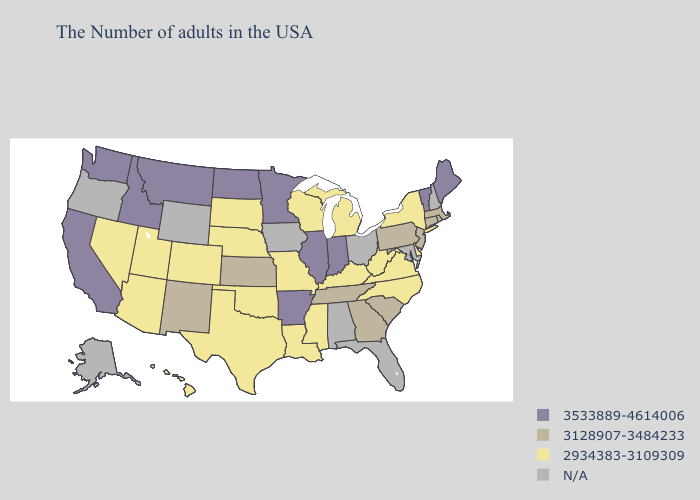Name the states that have a value in the range 3533889-4614006?
Keep it brief. Maine, Vermont, Indiana, Illinois, Arkansas, Minnesota, North Dakota, Montana, Idaho, California, Washington. Name the states that have a value in the range 3533889-4614006?
Short answer required. Maine, Vermont, Indiana, Illinois, Arkansas, Minnesota, North Dakota, Montana, Idaho, California, Washington. Does Arkansas have the highest value in the South?
Write a very short answer. Yes. What is the value of Connecticut?
Short answer required. 3128907-3484233. What is the lowest value in the West?
Keep it brief. 2934383-3109309. Name the states that have a value in the range N/A?
Quick response, please. New Hampshire, Maryland, Ohio, Florida, Alabama, Iowa, Wyoming, Oregon, Alaska. Name the states that have a value in the range 2934383-3109309?
Quick response, please. New York, Delaware, Virginia, North Carolina, West Virginia, Michigan, Kentucky, Wisconsin, Mississippi, Louisiana, Missouri, Nebraska, Oklahoma, Texas, South Dakota, Colorado, Utah, Arizona, Nevada, Hawaii. Name the states that have a value in the range N/A?
Be succinct. New Hampshire, Maryland, Ohio, Florida, Alabama, Iowa, Wyoming, Oregon, Alaska. Name the states that have a value in the range 3128907-3484233?
Short answer required. Massachusetts, Rhode Island, Connecticut, New Jersey, Pennsylvania, South Carolina, Georgia, Tennessee, Kansas, New Mexico. Does the map have missing data?
Write a very short answer. Yes. Name the states that have a value in the range 3128907-3484233?
Be succinct. Massachusetts, Rhode Island, Connecticut, New Jersey, Pennsylvania, South Carolina, Georgia, Tennessee, Kansas, New Mexico. What is the highest value in states that border New Jersey?
Be succinct. 3128907-3484233. What is the lowest value in the MidWest?
Quick response, please. 2934383-3109309. What is the highest value in states that border Colorado?
Give a very brief answer. 3128907-3484233. 